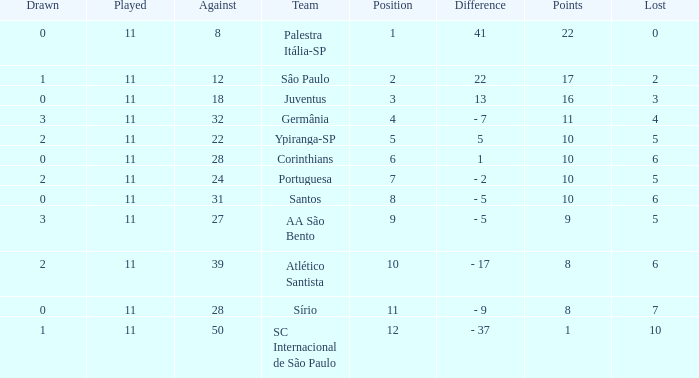What was the average Position for which the amount Drawn was less than 0? None. 